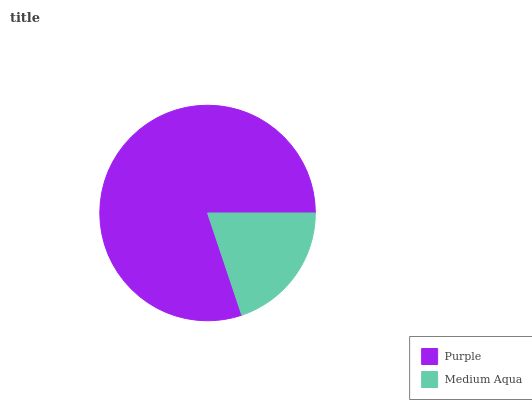Is Medium Aqua the minimum?
Answer yes or no. Yes. Is Purple the maximum?
Answer yes or no. Yes. Is Medium Aqua the maximum?
Answer yes or no. No. Is Purple greater than Medium Aqua?
Answer yes or no. Yes. Is Medium Aqua less than Purple?
Answer yes or no. Yes. Is Medium Aqua greater than Purple?
Answer yes or no. No. Is Purple less than Medium Aqua?
Answer yes or no. No. Is Purple the high median?
Answer yes or no. Yes. Is Medium Aqua the low median?
Answer yes or no. Yes. Is Medium Aqua the high median?
Answer yes or no. No. Is Purple the low median?
Answer yes or no. No. 